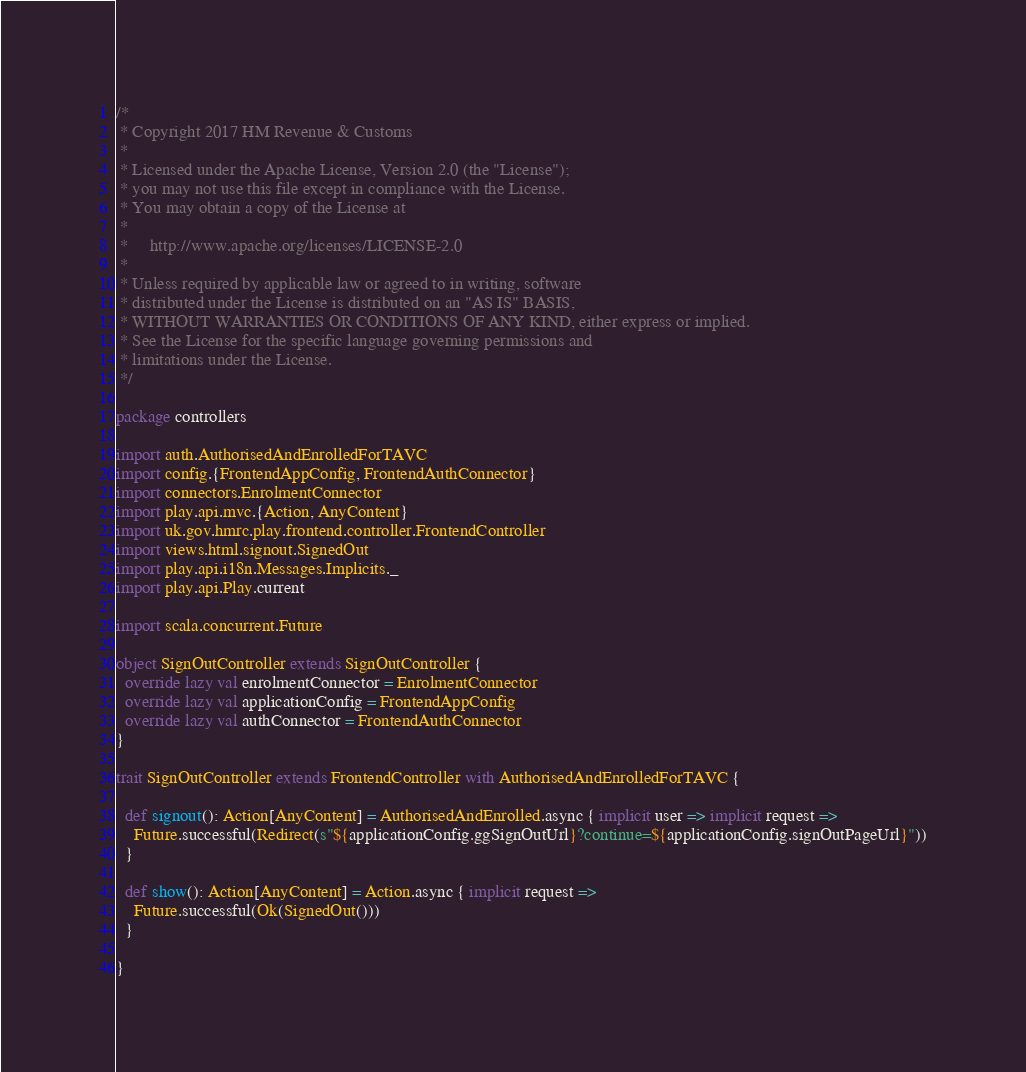Convert code to text. <code><loc_0><loc_0><loc_500><loc_500><_Scala_>/*
 * Copyright 2017 HM Revenue & Customs
 *
 * Licensed under the Apache License, Version 2.0 (the "License");
 * you may not use this file except in compliance with the License.
 * You may obtain a copy of the License at
 *
 *     http://www.apache.org/licenses/LICENSE-2.0
 *
 * Unless required by applicable law or agreed to in writing, software
 * distributed under the License is distributed on an "AS IS" BASIS,
 * WITHOUT WARRANTIES OR CONDITIONS OF ANY KIND, either express or implied.
 * See the License for the specific language governing permissions and
 * limitations under the License.
 */

package controllers

import auth.AuthorisedAndEnrolledForTAVC
import config.{FrontendAppConfig, FrontendAuthConnector}
import connectors.EnrolmentConnector
import play.api.mvc.{Action, AnyContent}
import uk.gov.hmrc.play.frontend.controller.FrontendController
import views.html.signout.SignedOut
import play.api.i18n.Messages.Implicits._
import play.api.Play.current

import scala.concurrent.Future

object SignOutController extends SignOutController {
  override lazy val enrolmentConnector = EnrolmentConnector
  override lazy val applicationConfig = FrontendAppConfig
  override lazy val authConnector = FrontendAuthConnector
}

trait SignOutController extends FrontendController with AuthorisedAndEnrolledForTAVC {

  def signout(): Action[AnyContent] = AuthorisedAndEnrolled.async { implicit user => implicit request =>
    Future.successful(Redirect(s"${applicationConfig.ggSignOutUrl}?continue=${applicationConfig.signOutPageUrl}"))
  }

  def show(): Action[AnyContent] = Action.async { implicit request =>
    Future.successful(Ok(SignedOut()))
  }

}
</code> 